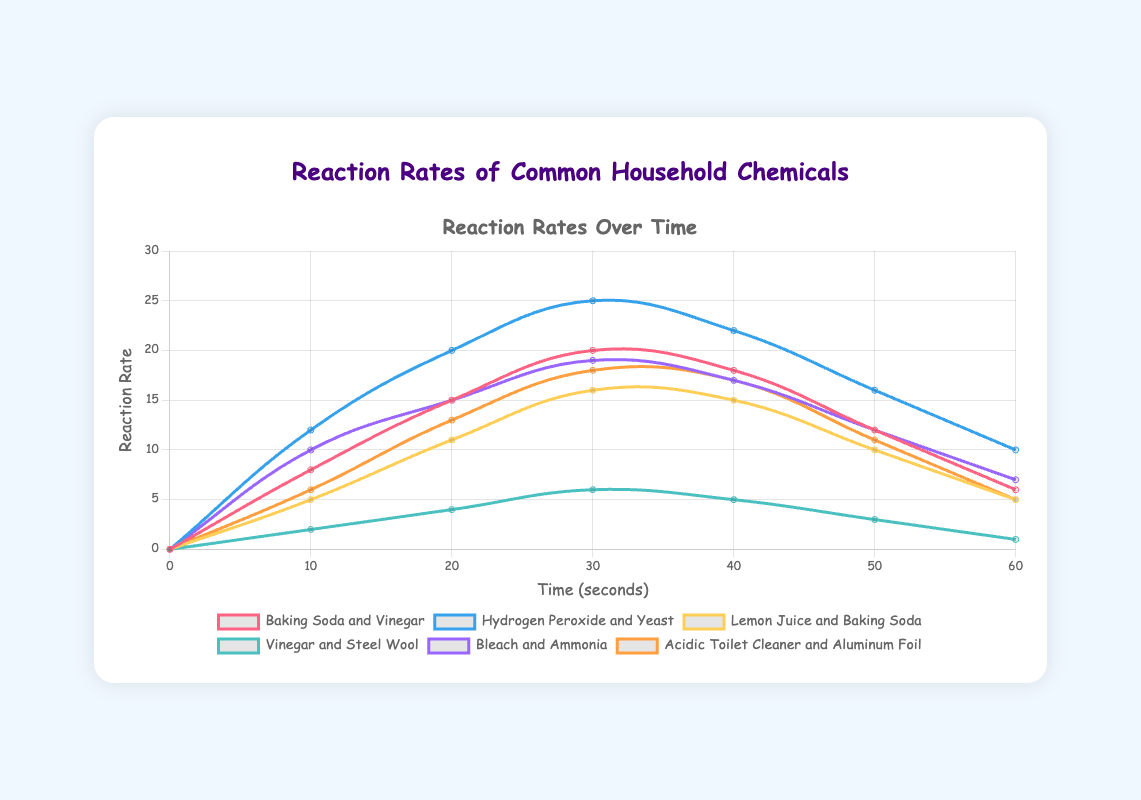Which reaction reaches its peak rate the quickest? To determine which reaction reaches its peak rate the quickest, we look at the time it takes for each chemical reaction to reach its highest reaction rate on the plot. The Hydrogen Peroxide and Yeast reaction hits its peak at 25 seconds, while the others take longer or have lower peaks at similar times.
Answer: Hydrogen Peroxide and Yeast At 30 seconds, which chemical reaction has the highest reaction rate? By looking at the reaction rates at the 30-second mark for all chemicals on the plot, we see that Hydrogen Peroxide and Yeast have a reaction rate of 25, which is the highest at that time compared to the others.
Answer: Hydrogen Peroxide and Yeast Which reaction is the slowest to pick up speed in the first 20 seconds? Check the slopes of the reaction rate curves during the first 20 seconds. Vinegar and Steel Wool have the slowest increase, with a rate of 4 units at 20 seconds.
Answer: Vinegar and Steel Wool What is the difference in reaction rate between Baking Soda and Vinegar and Hydrogen Peroxide and Yeast at 40 seconds? The reaction rate for Baking Soda and Vinegar at 40 seconds is 18, while for Hydrogen Peroxide and Yeast, it is 22. The difference is 22 - 18 = 4.
Answer: 4 Which reactions show a declining trend after reaching their peak rates? Observing the plot, after reaching their peak rates, reactions like Baking Soda and Vinegar, Hydrogen Peroxide and Yeast, Lemon Juice and Baking Soda, Bleach and Ammonia, and Acidic Toilet Cleaner and Aluminum Foil show a declining pattern.
Answer: Baking Soda and Vinegar, Hydrogen Peroxide and Yeast, Lemon Juice and Baking Soda, Bleach and Ammonia, Acidic Toilet Cleaner and Aluminum Foil How much faster does Hydrogen Peroxide and Yeast reach its peak compared to Lemon Juice and Baking Soda? Hydrogen Peroxide and Yeast reach their peak at 30 seconds, while Lemon Juice and Baking Soda peak at 30 seconds as well. Thus, they peak at the same time.
Answer: 0 seconds Which reaction has the smallest peak rate? To find the reaction with the smallest peak rate, observe the peak values of each line. Vinegar and Steel Wool reach a peak rate of 6, which is the smallest peak rate among the reactions.
Answer: Vinegar and Steel Wool What is the average reaction rate of Acidic Toilet Cleaner and Aluminum Foil over the first minute? Sum the reaction rates of Acidic Toilet Cleaner and Aluminum Foil (0, 6, 13, 18, 17, 11, 5) and divide by 7 to get the average: (0 + 6 + 13 + 18 + 17 + 11 + 5) / 7 = 70 / 7 = 10.
Answer: 10 Which chemical reaction has a rate of 19 at some point in the graph? Identify the reaction rate of 19 in the graph. Both Bleach and Ammonia reach a reaction rate of 19 at 30 seconds.
Answer: Bleach and Ammonia 